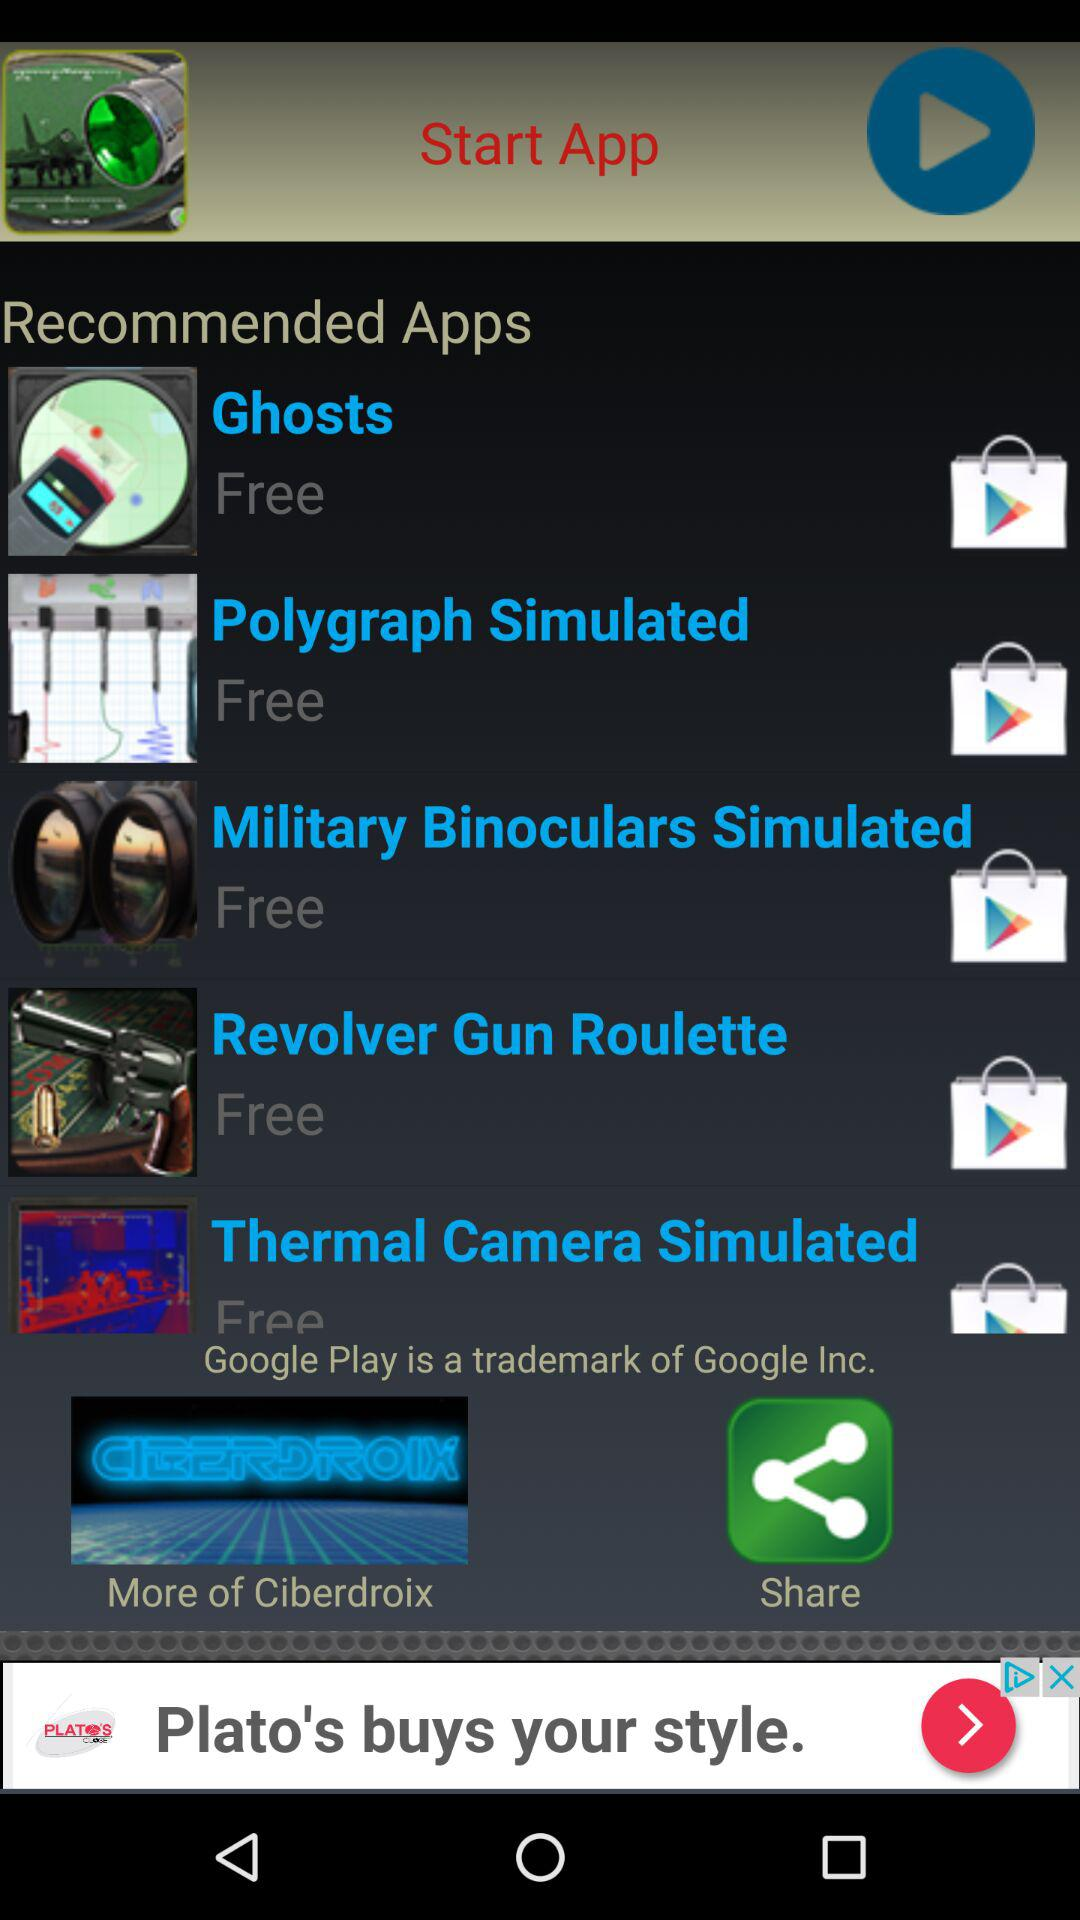What is the price of the "Ghosts" application? The "Ghosts" application is free. 